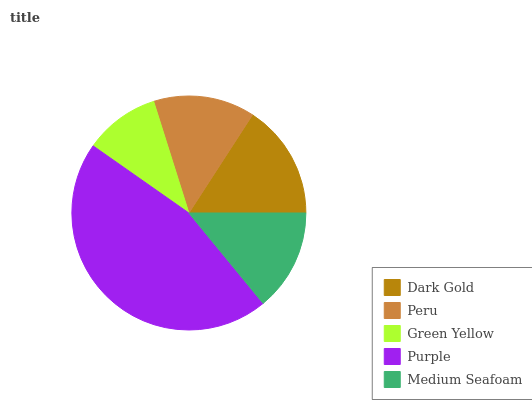Is Green Yellow the minimum?
Answer yes or no. Yes. Is Purple the maximum?
Answer yes or no. Yes. Is Peru the minimum?
Answer yes or no. No. Is Peru the maximum?
Answer yes or no. No. Is Dark Gold greater than Peru?
Answer yes or no. Yes. Is Peru less than Dark Gold?
Answer yes or no. Yes. Is Peru greater than Dark Gold?
Answer yes or no. No. Is Dark Gold less than Peru?
Answer yes or no. No. Is Medium Seafoam the high median?
Answer yes or no. Yes. Is Medium Seafoam the low median?
Answer yes or no. Yes. Is Peru the high median?
Answer yes or no. No. Is Dark Gold the low median?
Answer yes or no. No. 